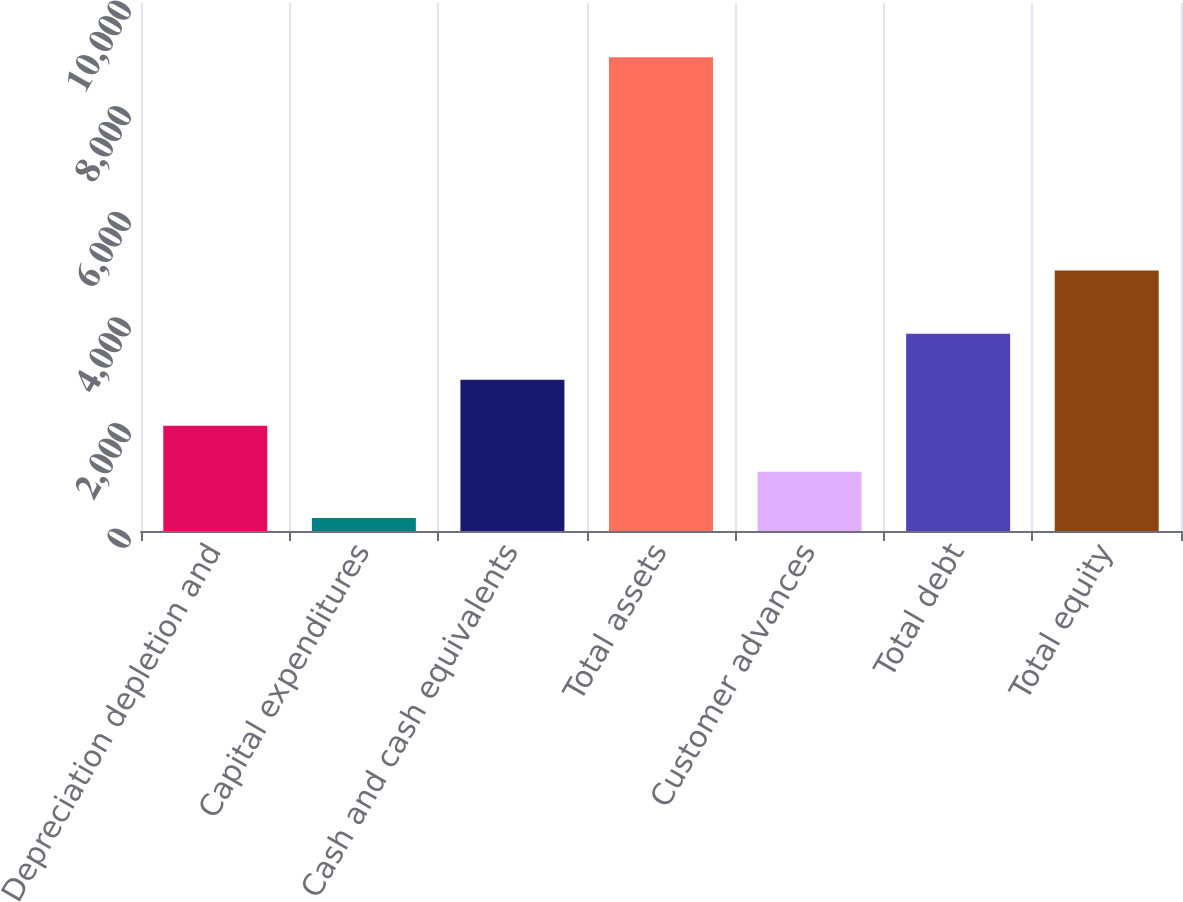Convert chart. <chart><loc_0><loc_0><loc_500><loc_500><bar_chart><fcel>Depreciation depletion and<fcel>Capital expenditures<fcel>Cash and cash equivalents<fcel>Total assets<fcel>Customer advances<fcel>Total debt<fcel>Total equity<nl><fcel>1992.66<fcel>247.2<fcel>2865.39<fcel>8974.5<fcel>1119.93<fcel>3738.12<fcel>4932.9<nl></chart> 